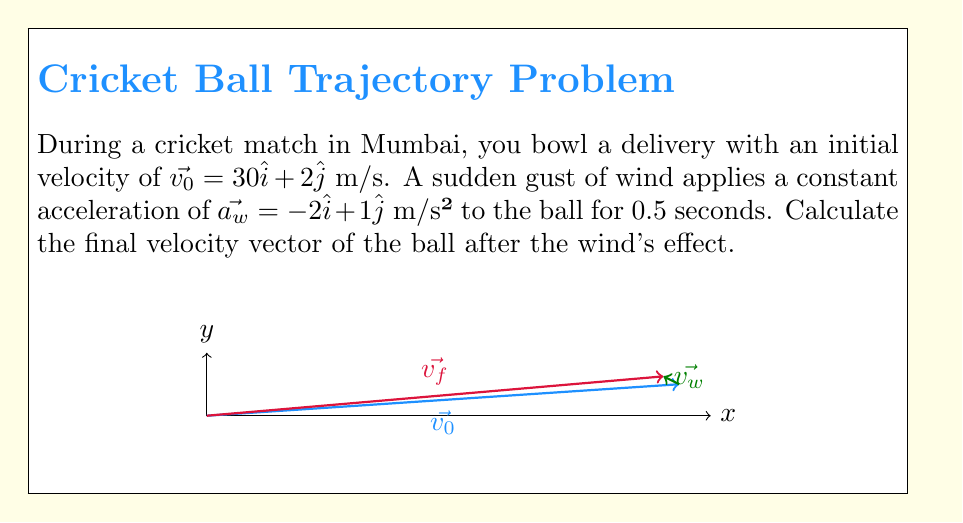Could you help me with this problem? Let's approach this step-by-step:

1) First, we need to find the change in velocity due to the wind ($\vec{v_w}$). We can do this using the equation:

   $\vec{v_w} = \vec{a_w} \cdot t$

   Where $\vec{a_w}$ is the wind acceleration and $t$ is the time.

2) Substituting the values:

   $\vec{v_w} = (-2\hat{i} + 1\hat{j}) \cdot 0.5$
   $\vec{v_w} = -1\hat{i} + 0.5\hat{j}$ m/s

3) Now, we can find the final velocity ($\vec{v_f}$) by adding the initial velocity ($\vec{v_0}$) and the change in velocity due to wind ($\vec{v_w}$):

   $\vec{v_f} = \vec{v_0} + \vec{v_w}$

4) Substituting the values:

   $\vec{v_f} = (30\hat{i} + 2\hat{j}) + (-1\hat{i} + 0.5\hat{j})$

5) Adding the components:

   $\vec{v_f} = (30 - 1)\hat{i} + (2 + 0.5)\hat{j}$
   $\vec{v_f} = 29\hat{i} + 2.5\hat{j}$ m/s

Therefore, the final velocity vector of the ball after the wind's effect is $29\hat{i} + 2.5\hat{j}$ m/s.
Answer: $29\hat{i} + 2.5\hat{j}$ m/s 